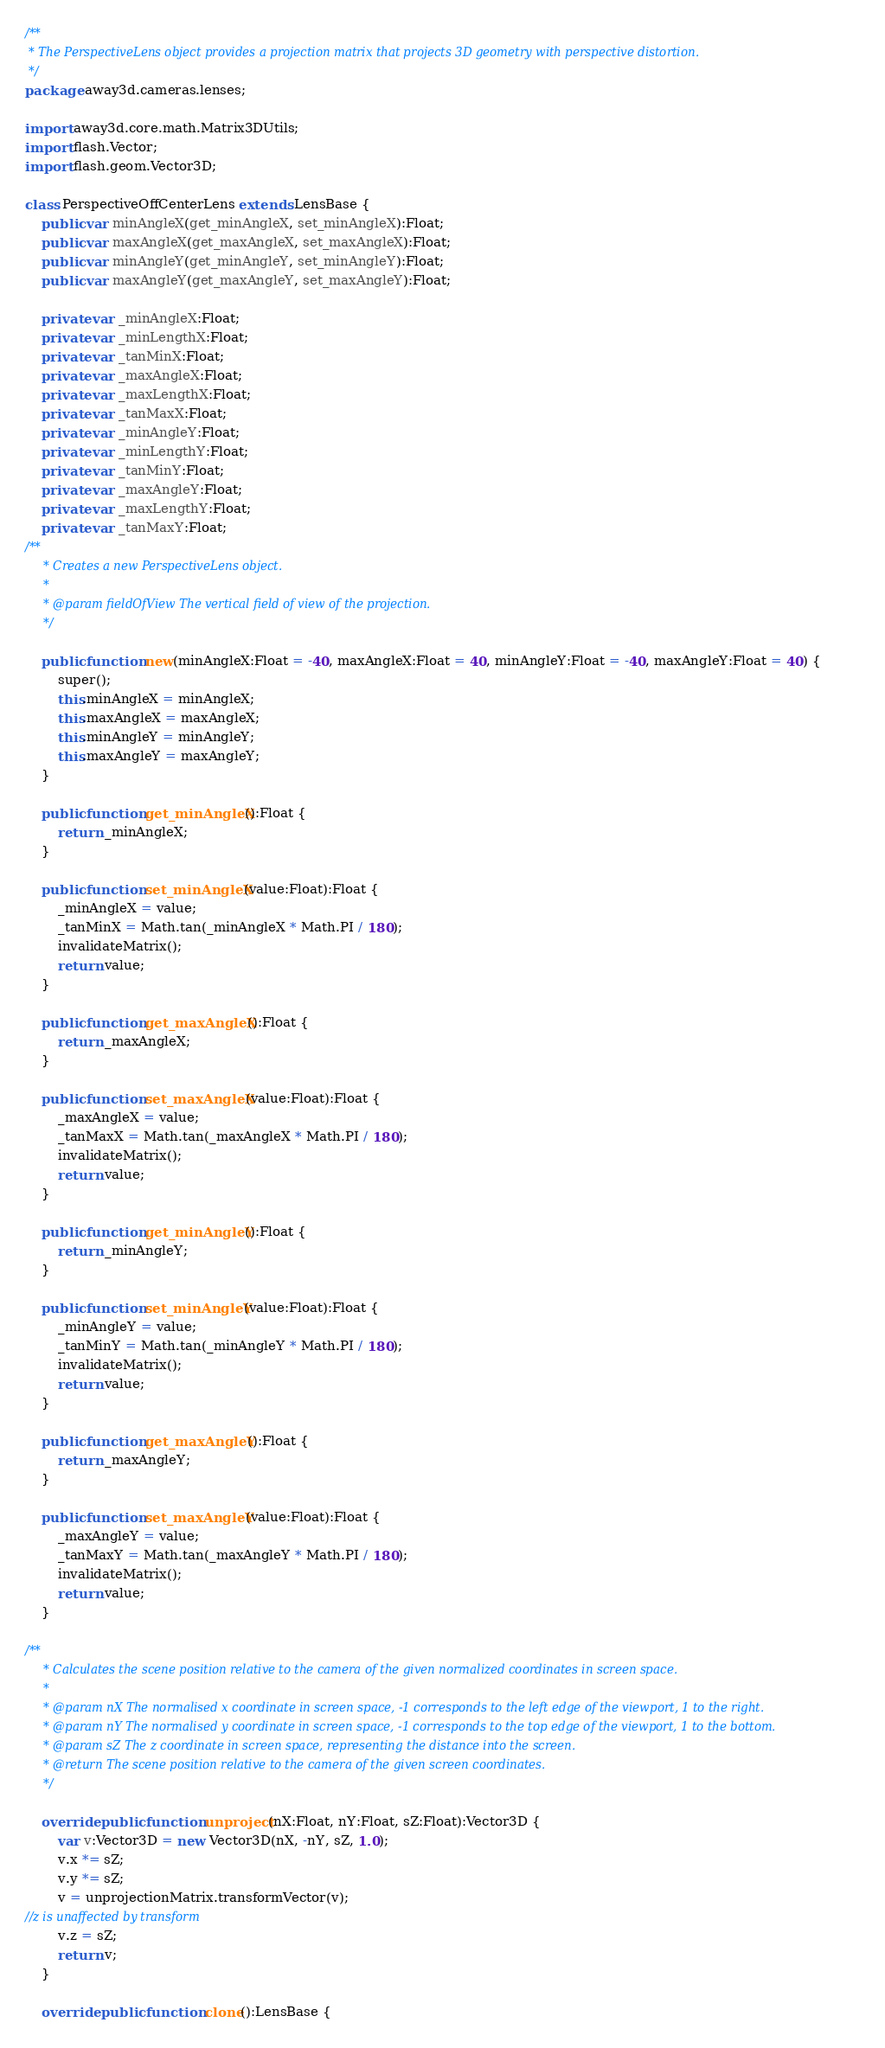<code> <loc_0><loc_0><loc_500><loc_500><_Haxe_>/**
 * The PerspectiveLens object provides a projection matrix that projects 3D geometry with perspective distortion.
 */
package away3d.cameras.lenses;

import away3d.core.math.Matrix3DUtils;
import flash.Vector;
import flash.geom.Vector3D;

class PerspectiveOffCenterLens extends LensBase {
    public var minAngleX(get_minAngleX, set_minAngleX):Float;
    public var maxAngleX(get_maxAngleX, set_maxAngleX):Float;
    public var minAngleY(get_minAngleY, set_minAngleY):Float;
    public var maxAngleY(get_maxAngleY, set_maxAngleY):Float;

    private var _minAngleX:Float;
    private var _minLengthX:Float;
    private var _tanMinX:Float;
    private var _maxAngleX:Float;
    private var _maxLengthX:Float;
    private var _tanMaxX:Float;
    private var _minAngleY:Float;
    private var _minLengthY:Float;
    private var _tanMinY:Float;
    private var _maxAngleY:Float;
    private var _maxLengthY:Float;
    private var _tanMaxY:Float;
/**
	 * Creates a new PerspectiveLens object.
	 *
	 * @param fieldOfView The vertical field of view of the projection.
	 */

    public function new(minAngleX:Float = -40, maxAngleX:Float = 40, minAngleY:Float = -40, maxAngleY:Float = 40) {
        super();
        this.minAngleX = minAngleX;
        this.maxAngleX = maxAngleX;
        this.minAngleY = minAngleY;
        this.maxAngleY = maxAngleY;
    }

    public function get_minAngleX():Float {
        return _minAngleX;
    }

    public function set_minAngleX(value:Float):Float {
        _minAngleX = value;
        _tanMinX = Math.tan(_minAngleX * Math.PI / 180);
        invalidateMatrix();
        return value;
    }

    public function get_maxAngleX():Float {
        return _maxAngleX;
    }

    public function set_maxAngleX(value:Float):Float {
        _maxAngleX = value;
        _tanMaxX = Math.tan(_maxAngleX * Math.PI / 180);
        invalidateMatrix();
        return value;
    }

    public function get_minAngleY():Float {
        return _minAngleY;
    }

    public function set_minAngleY(value:Float):Float {
        _minAngleY = value;
        _tanMinY = Math.tan(_minAngleY * Math.PI / 180);
        invalidateMatrix();
        return value;
    }

    public function get_maxAngleY():Float {
        return _maxAngleY;
    }

    public function set_maxAngleY(value:Float):Float {
        _maxAngleY = value;
        _tanMaxY = Math.tan(_maxAngleY * Math.PI / 180);
        invalidateMatrix();
        return value;
    }

/**
	 * Calculates the scene position relative to the camera of the given normalized coordinates in screen space.
	 *
	 * @param nX The normalised x coordinate in screen space, -1 corresponds to the left edge of the viewport, 1 to the right.
	 * @param nY The normalised y coordinate in screen space, -1 corresponds to the top edge of the viewport, 1 to the bottom.
	 * @param sZ The z coordinate in screen space, representing the distance into the screen.
	 * @return The scene position relative to the camera of the given screen coordinates.
	 */

    override public function unproject(nX:Float, nY:Float, sZ:Float):Vector3D {
        var v:Vector3D = new Vector3D(nX, -nY, sZ, 1.0);
        v.x *= sZ;
        v.y *= sZ;
        v = unprojectionMatrix.transformVector(v);
//z is unaffected by transform
        v.z = sZ;
        return v;
    }

    override public function clone():LensBase {</code> 